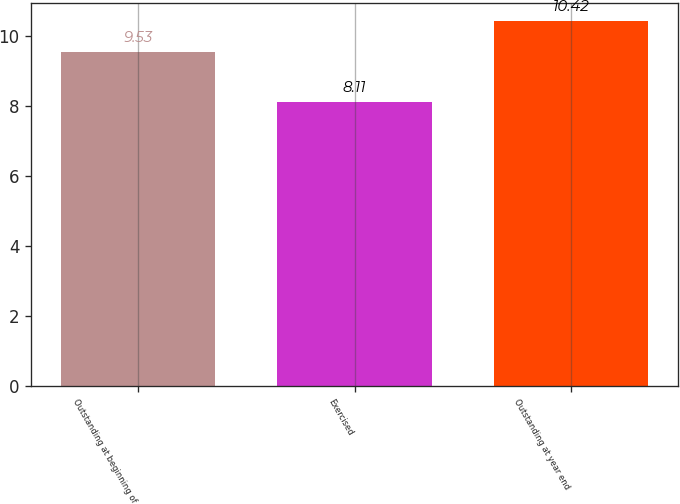Convert chart. <chart><loc_0><loc_0><loc_500><loc_500><bar_chart><fcel>Outstanding at beginning of<fcel>Exercised<fcel>Outstanding at year end<nl><fcel>9.53<fcel>8.11<fcel>10.42<nl></chart> 